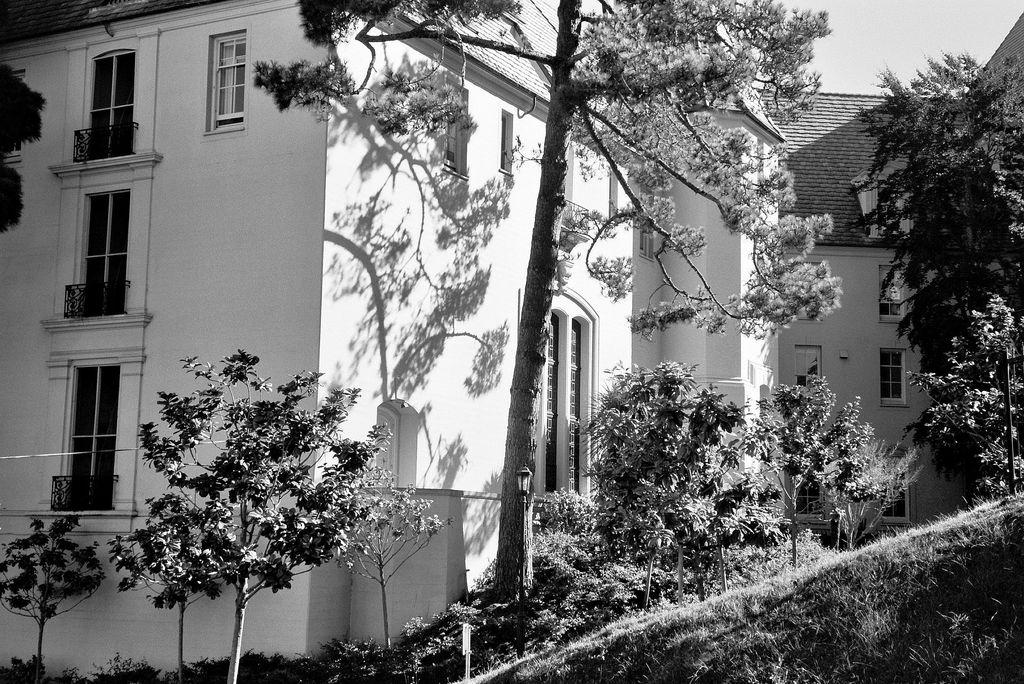What is the color scheme of the image? The image is black and white. What type of structures are present in the image? There are buildings in the image. What features can be seen on the buildings? The buildings have windows, doors, and balconies. What type of vegetation is near the buildings? There are trees and plants near the buildings. Can you tell me how many fowl are protesting in the alley in the image? There are no fowl or alley present in the image; it features black and white buildings with windows, doors, and balconies, surrounded by trees and plants. 